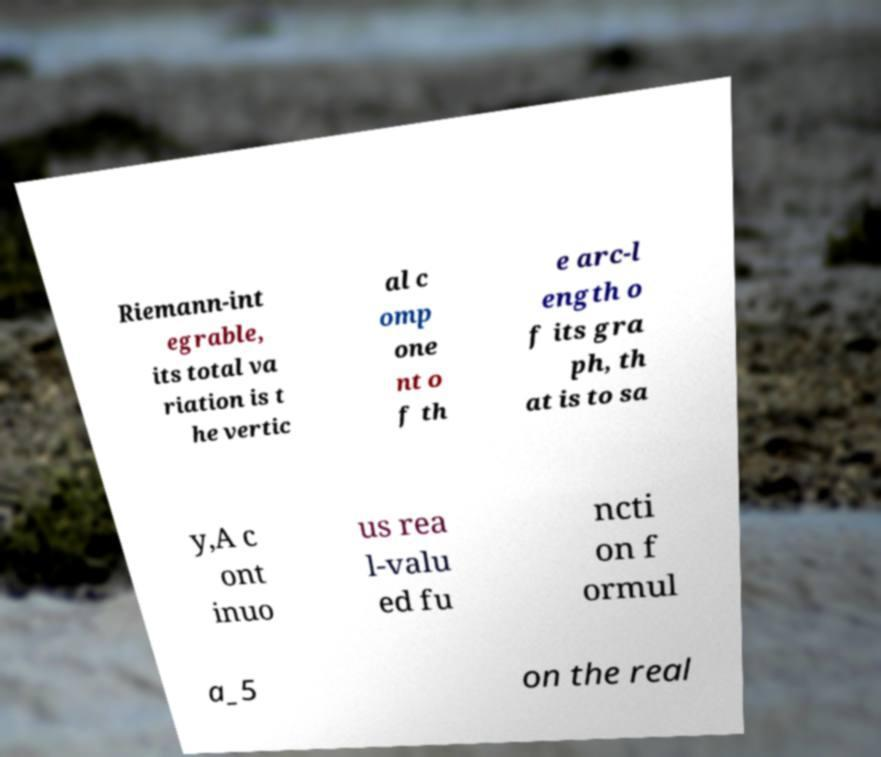Could you assist in decoding the text presented in this image and type it out clearly? Riemann-int egrable, its total va riation is t he vertic al c omp one nt o f th e arc-l ength o f its gra ph, th at is to sa y,A c ont inuo us rea l-valu ed fu ncti on f ormul a_5 on the real 